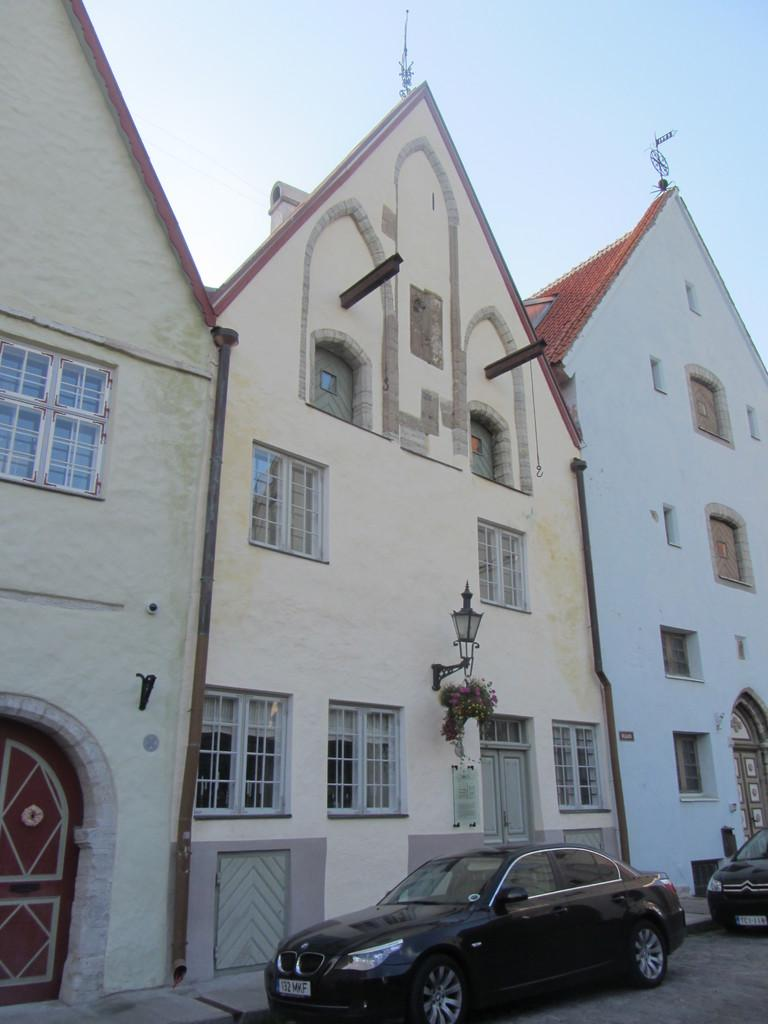What can be seen parked on the side of the road in the image? There are cars parked on the side of the road in the image. What else is visible in the image besides the parked cars? There are lights and houses visible in the image. What is the condition of the sky in the background of the image? The sky is plain in the background of the image. What type of animals can be seen at the zoo in the image? There is no zoo present in the image; it features parked cars, lights, houses, and a plain sky. 